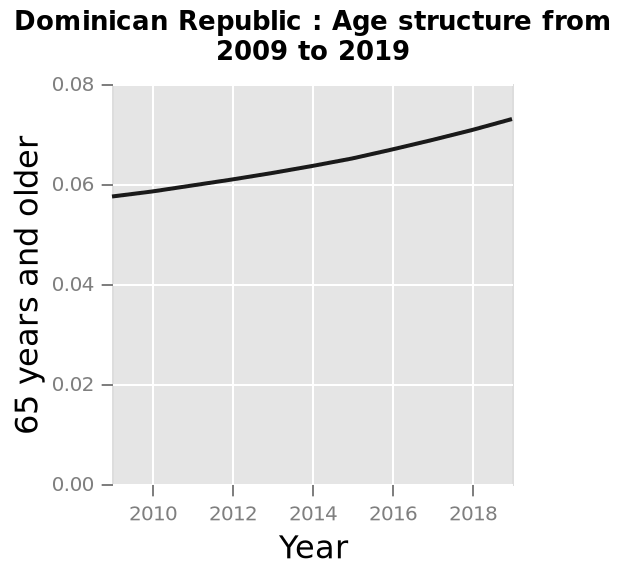<image>
What demographic group does the percentage refer to? The percentage refers to the population of individuals aged 65 and above. please summary the statistics and relations of the chart Between 2009 and 2019 the percentage of over-65's shows a steady upward trend. Did the percentage of over-65's increase or decrease during the mentioned time period?  The percentage of over-65's increased during the mentioned time period. What is the title/figure of the line graph? The title or figure of the line graph is "Dominican Republic: Age structure from 2009 to 2019". Does the percentage refer to the population of individuals aged 64 and above? No.The percentage refers to the population of individuals aged 65 and above. 